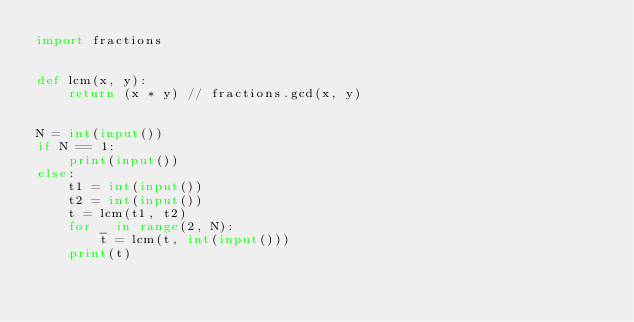<code> <loc_0><loc_0><loc_500><loc_500><_Python_>import fractions


def lcm(x, y):
    return (x * y) // fractions.gcd(x, y)


N = int(input())
if N == 1:
    print(input())
else:
    t1 = int(input())
    t2 = int(input())
    t = lcm(t1, t2)
    for _ in range(2, N):
        t = lcm(t, int(input()))
    print(t)
</code> 